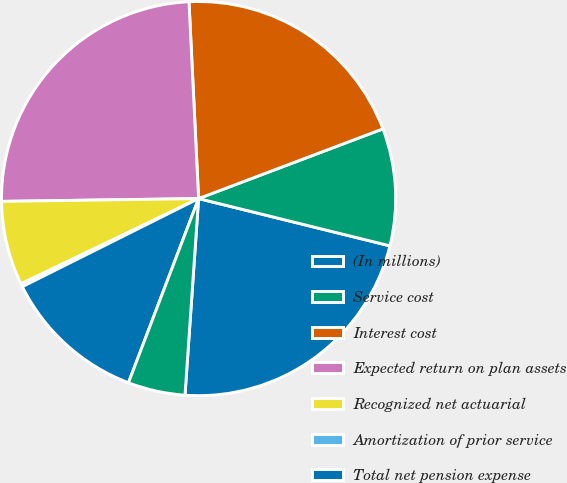Convert chart. <chart><loc_0><loc_0><loc_500><loc_500><pie_chart><fcel>(In millions)<fcel>Service cost<fcel>Interest cost<fcel>Expected return on plan assets<fcel>Recognized net actuarial<fcel>Amortization of prior service<fcel>Total net pension expense<fcel>Total net postretirement<nl><fcel>22.24%<fcel>9.61%<fcel>20.02%<fcel>24.45%<fcel>6.9%<fcel>0.25%<fcel>11.83%<fcel>4.69%<nl></chart> 